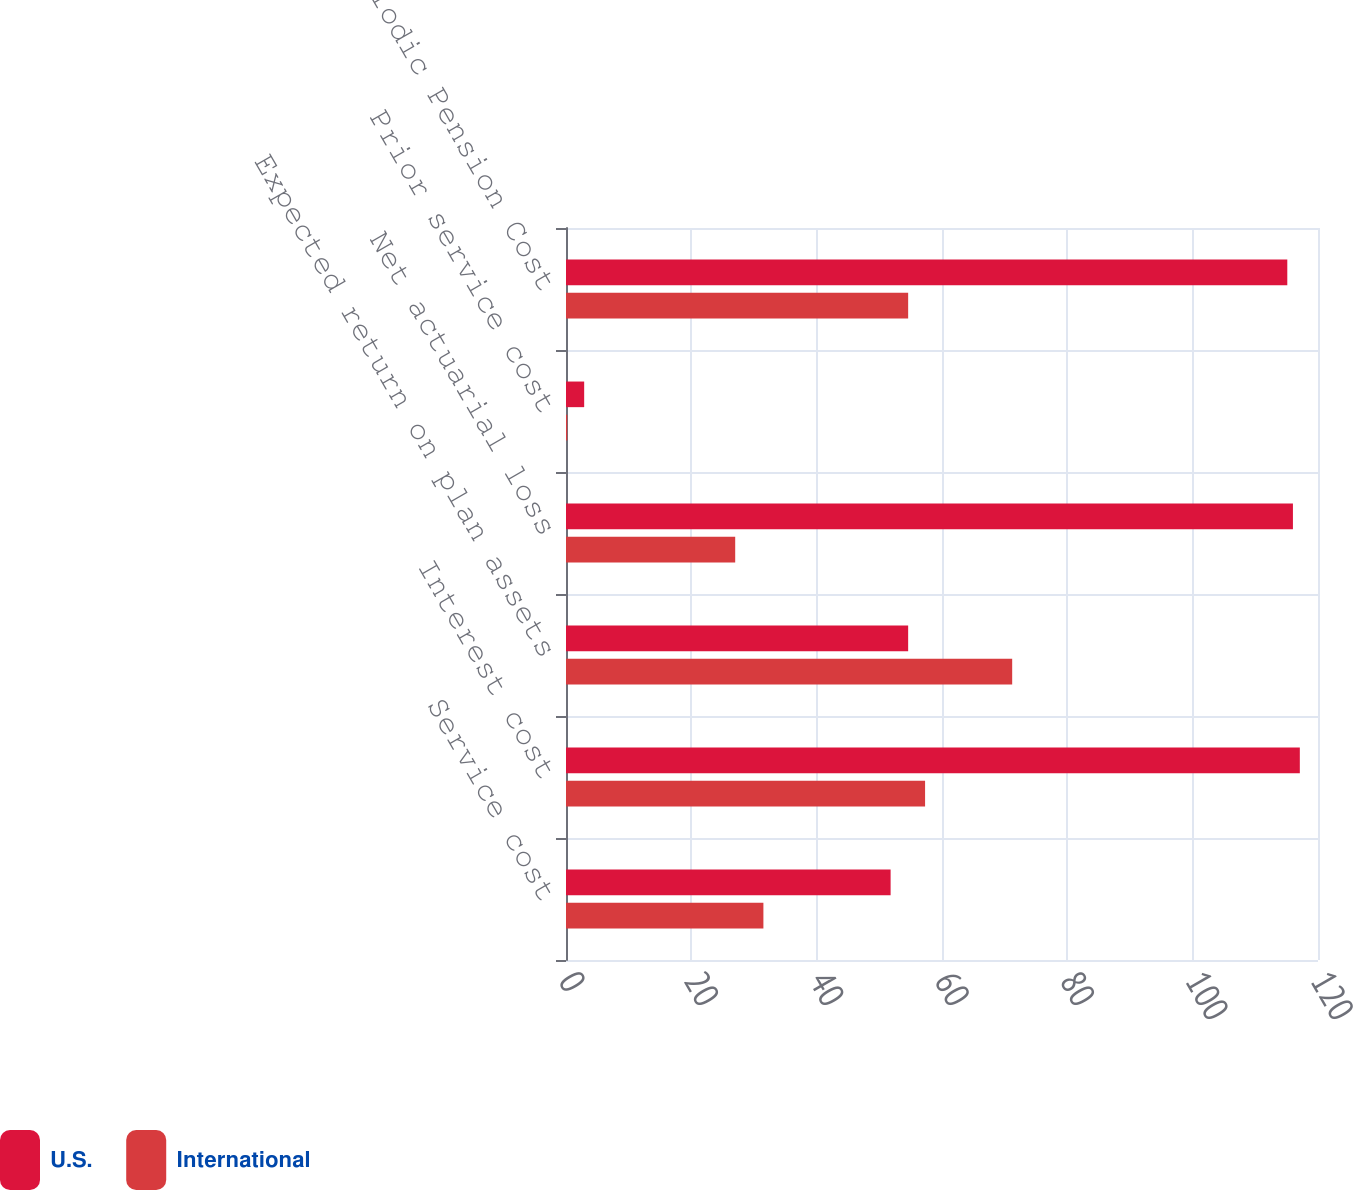<chart> <loc_0><loc_0><loc_500><loc_500><stacked_bar_chart><ecel><fcel>Service cost<fcel>Interest cost<fcel>Expected return on plan assets<fcel>Net actuarial loss<fcel>Prior service cost<fcel>Net Periodic Pension Cost<nl><fcel>U.S.<fcel>51.8<fcel>117.1<fcel>54.6<fcel>116<fcel>2.9<fcel>115.1<nl><fcel>International<fcel>31.5<fcel>57.3<fcel>71.2<fcel>27<fcel>0.2<fcel>54.6<nl></chart> 